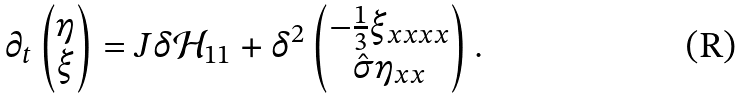<formula> <loc_0><loc_0><loc_500><loc_500>\partial _ { t } \begin{pmatrix} \eta \\ \xi \end{pmatrix} = J \delta \mathcal { H } _ { 1 1 } + \delta ^ { 2 } \begin{pmatrix} - \frac { 1 } { 3 } \xi _ { x x x x } \\ \hat { \sigma } \eta _ { x x } \end{pmatrix} .</formula> 